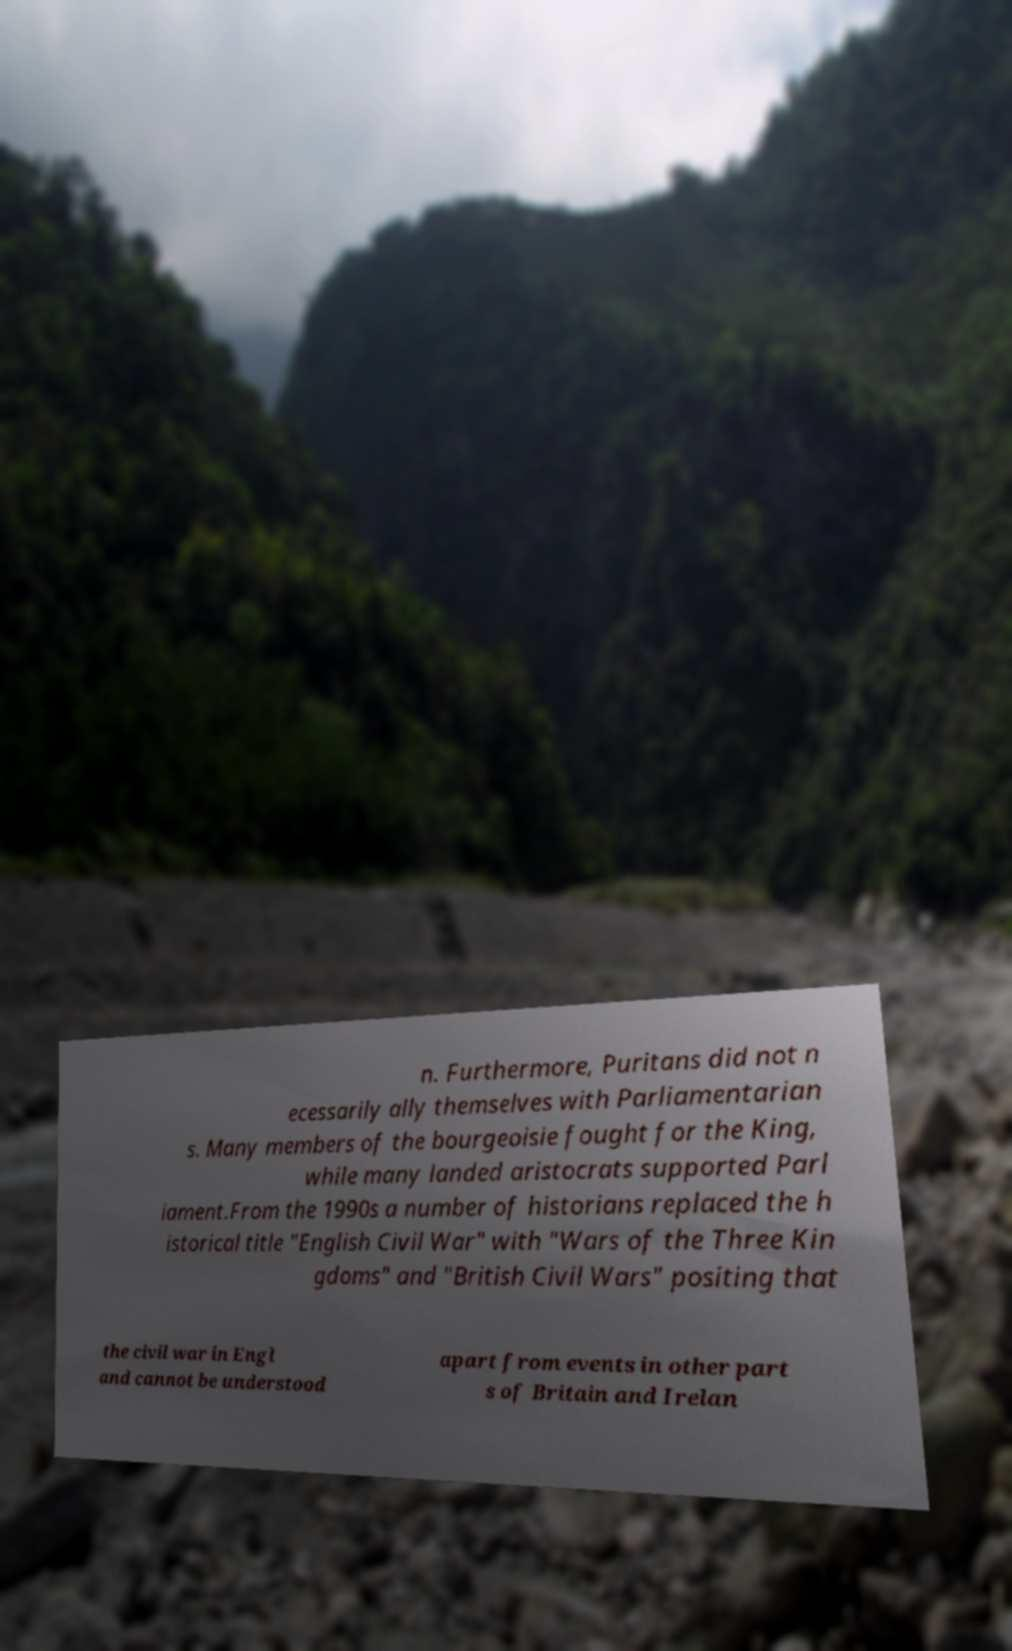For documentation purposes, I need the text within this image transcribed. Could you provide that? n. Furthermore, Puritans did not n ecessarily ally themselves with Parliamentarian s. Many members of the bourgeoisie fought for the King, while many landed aristocrats supported Parl iament.From the 1990s a number of historians replaced the h istorical title "English Civil War" with "Wars of the Three Kin gdoms" and "British Civil Wars" positing that the civil war in Engl and cannot be understood apart from events in other part s of Britain and Irelan 